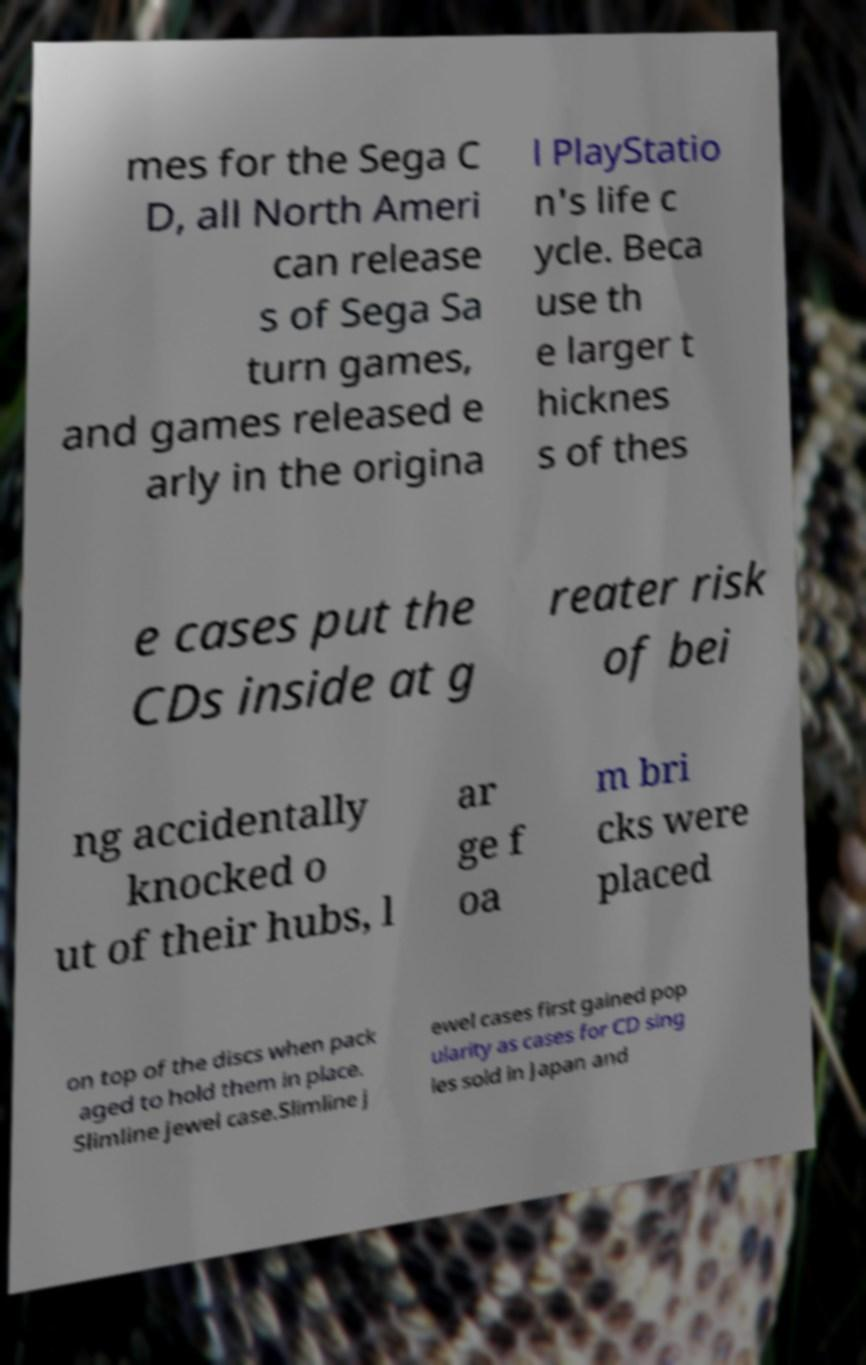Please read and relay the text visible in this image. What does it say? mes for the Sega C D, all North Ameri can release s of Sega Sa turn games, and games released e arly in the origina l PlayStatio n's life c ycle. Beca use th e larger t hicknes s of thes e cases put the CDs inside at g reater risk of bei ng accidentally knocked o ut of their hubs, l ar ge f oa m bri cks were placed on top of the discs when pack aged to hold them in place. Slimline jewel case.Slimline j ewel cases first gained pop ularity as cases for CD sing les sold in Japan and 